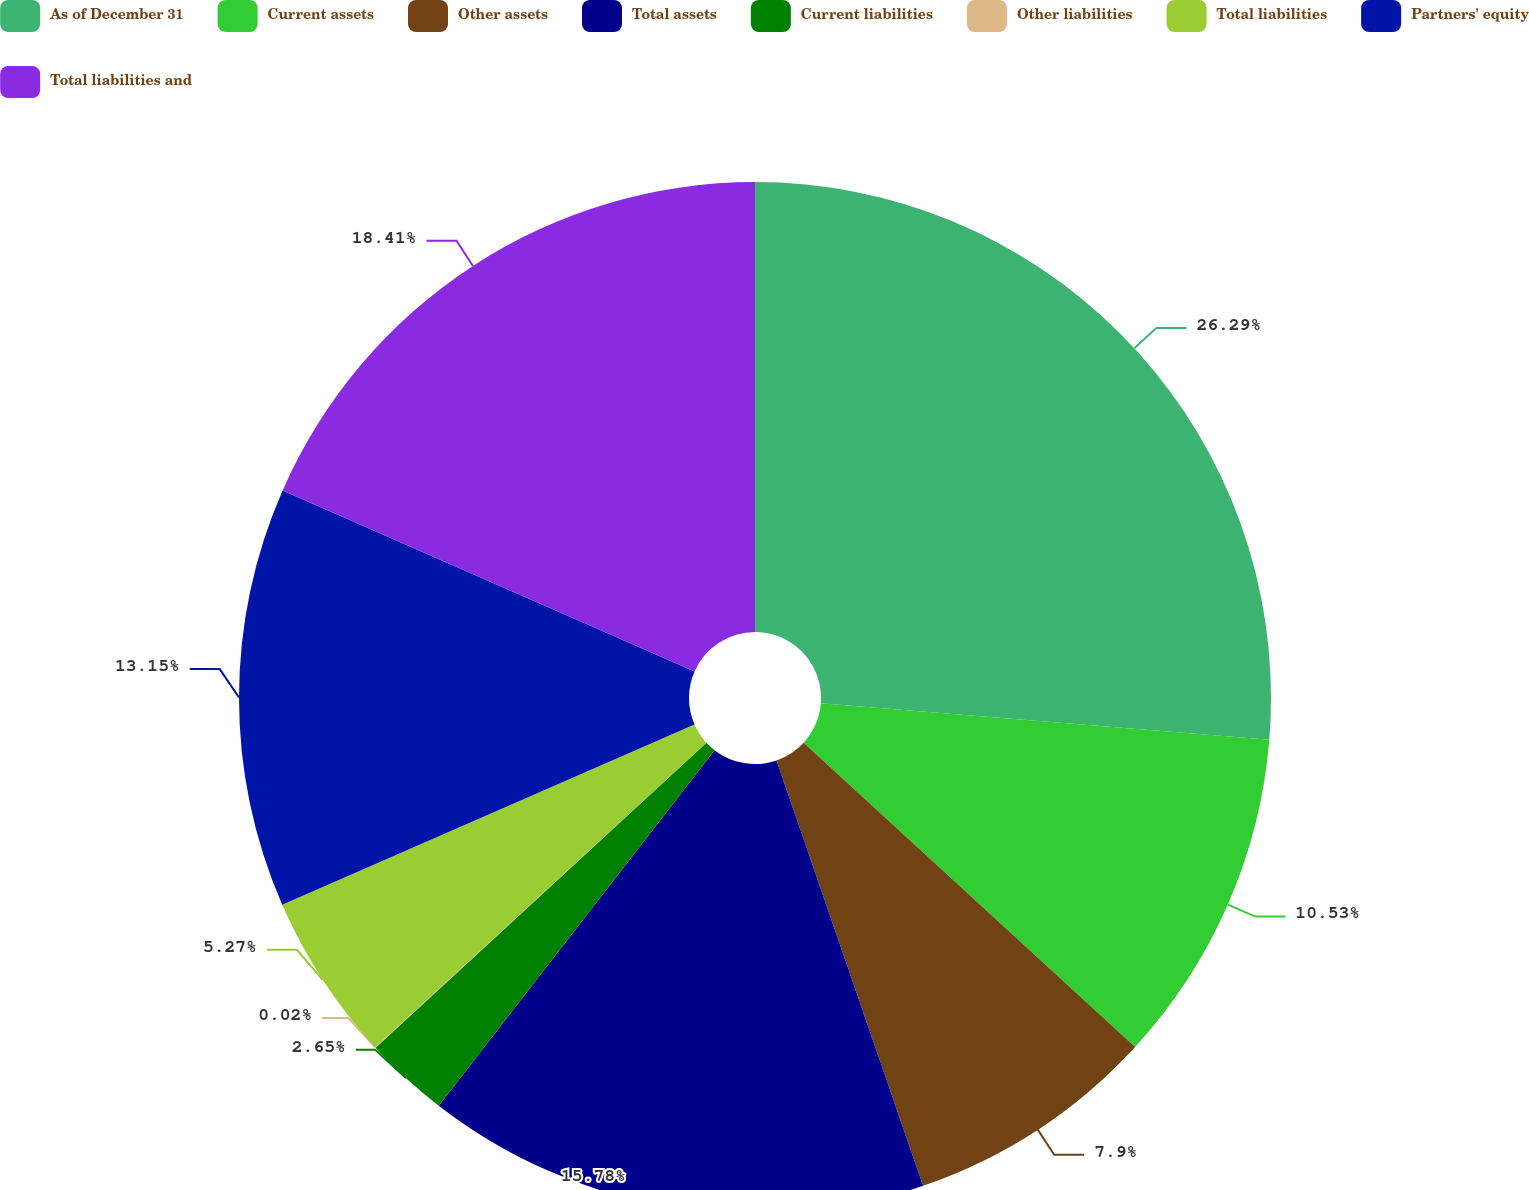Convert chart. <chart><loc_0><loc_0><loc_500><loc_500><pie_chart><fcel>As of December 31<fcel>Current assets<fcel>Other assets<fcel>Total assets<fcel>Current liabilities<fcel>Other liabilities<fcel>Total liabilities<fcel>Partners' equity<fcel>Total liabilities and<nl><fcel>26.29%<fcel>10.53%<fcel>7.9%<fcel>15.78%<fcel>2.65%<fcel>0.02%<fcel>5.27%<fcel>13.15%<fcel>18.41%<nl></chart> 